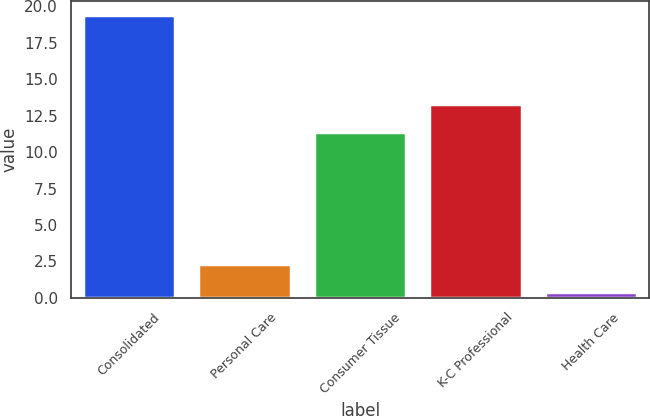Convert chart to OTSL. <chart><loc_0><loc_0><loc_500><loc_500><bar_chart><fcel>Consolidated<fcel>Personal Care<fcel>Consumer Tissue<fcel>K-C Professional<fcel>Health Care<nl><fcel>19.4<fcel>2.3<fcel>11.4<fcel>13.3<fcel>0.4<nl></chart> 